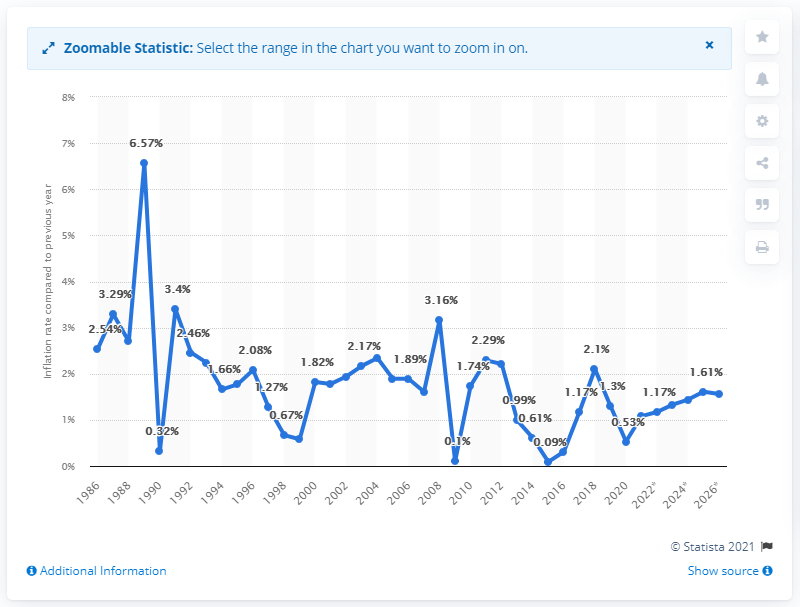Mention a couple of crucial points in this snapshot. In 2020, the inflation rate in France was 0.53%. 